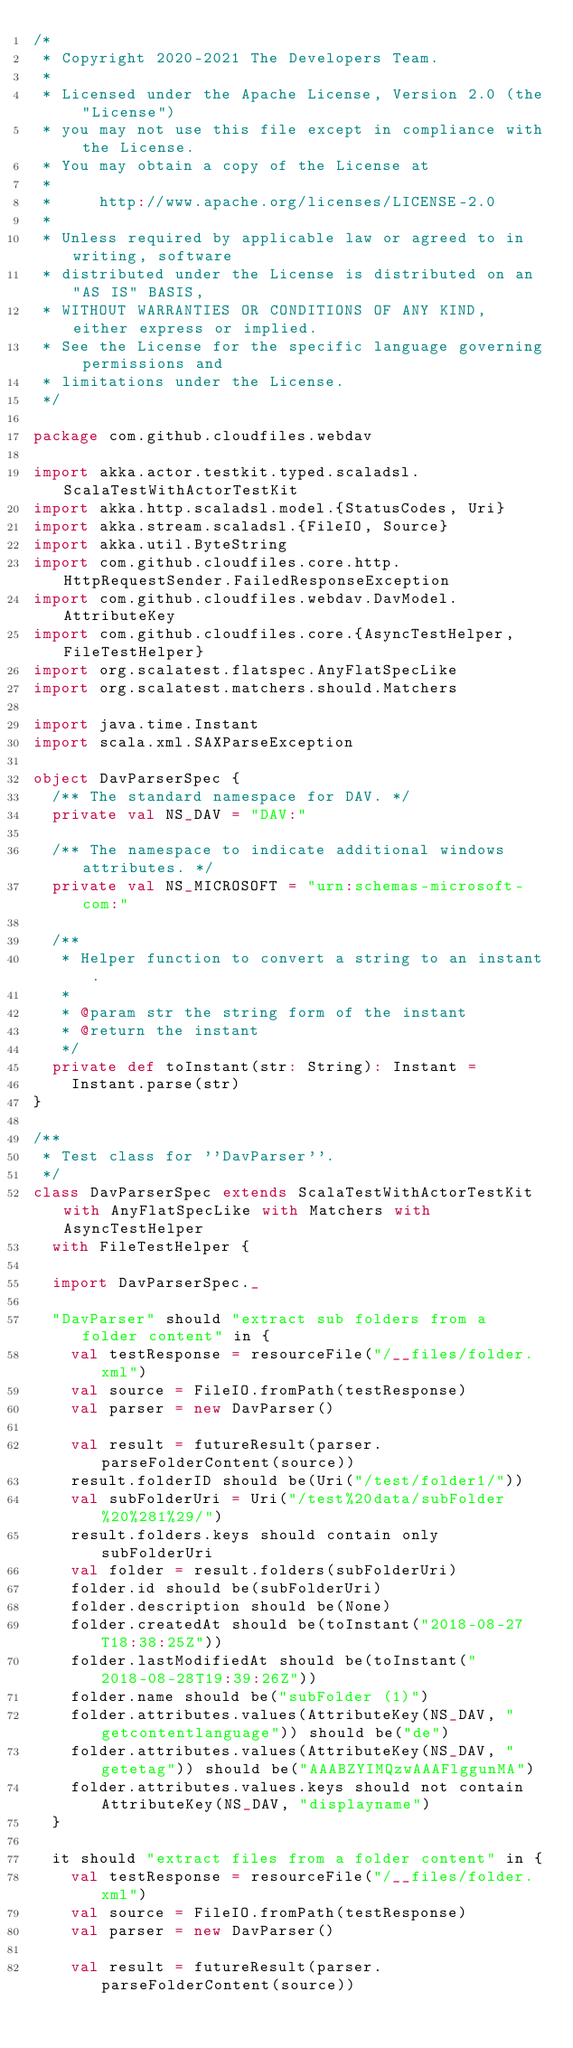Convert code to text. <code><loc_0><loc_0><loc_500><loc_500><_Scala_>/*
 * Copyright 2020-2021 The Developers Team.
 *
 * Licensed under the Apache License, Version 2.0 (the "License")
 * you may not use this file except in compliance with the License.
 * You may obtain a copy of the License at
 *
 *     http://www.apache.org/licenses/LICENSE-2.0
 *
 * Unless required by applicable law or agreed to in writing, software
 * distributed under the License is distributed on an "AS IS" BASIS,
 * WITHOUT WARRANTIES OR CONDITIONS OF ANY KIND, either express or implied.
 * See the License for the specific language governing permissions and
 * limitations under the License.
 */

package com.github.cloudfiles.webdav

import akka.actor.testkit.typed.scaladsl.ScalaTestWithActorTestKit
import akka.http.scaladsl.model.{StatusCodes, Uri}
import akka.stream.scaladsl.{FileIO, Source}
import akka.util.ByteString
import com.github.cloudfiles.core.http.HttpRequestSender.FailedResponseException
import com.github.cloudfiles.webdav.DavModel.AttributeKey
import com.github.cloudfiles.core.{AsyncTestHelper, FileTestHelper}
import org.scalatest.flatspec.AnyFlatSpecLike
import org.scalatest.matchers.should.Matchers

import java.time.Instant
import scala.xml.SAXParseException

object DavParserSpec {
  /** The standard namespace for DAV. */
  private val NS_DAV = "DAV:"

  /** The namespace to indicate additional windows attributes. */
  private val NS_MICROSOFT = "urn:schemas-microsoft-com:"

  /**
   * Helper function to convert a string to an instant.
   *
   * @param str the string form of the instant
   * @return the instant
   */
  private def toInstant(str: String): Instant =
    Instant.parse(str)
}

/**
 * Test class for ''DavParser''.
 */
class DavParserSpec extends ScalaTestWithActorTestKit with AnyFlatSpecLike with Matchers with AsyncTestHelper
  with FileTestHelper {

  import DavParserSpec._

  "DavParser" should "extract sub folders from a folder content" in {
    val testResponse = resourceFile("/__files/folder.xml")
    val source = FileIO.fromPath(testResponse)
    val parser = new DavParser()

    val result = futureResult(parser.parseFolderContent(source))
    result.folderID should be(Uri("/test/folder1/"))
    val subFolderUri = Uri("/test%20data/subFolder%20%281%29/")
    result.folders.keys should contain only subFolderUri
    val folder = result.folders(subFolderUri)
    folder.id should be(subFolderUri)
    folder.description should be(None)
    folder.createdAt should be(toInstant("2018-08-27T18:38:25Z"))
    folder.lastModifiedAt should be(toInstant("2018-08-28T19:39:26Z"))
    folder.name should be("subFolder (1)")
    folder.attributes.values(AttributeKey(NS_DAV, "getcontentlanguage")) should be("de")
    folder.attributes.values(AttributeKey(NS_DAV, "getetag")) should be("AAABZYIMQzwAAAFlggunMA")
    folder.attributes.values.keys should not contain AttributeKey(NS_DAV, "displayname")
  }

  it should "extract files from a folder content" in {
    val testResponse = resourceFile("/__files/folder.xml")
    val source = FileIO.fromPath(testResponse)
    val parser = new DavParser()

    val result = futureResult(parser.parseFolderContent(source))</code> 